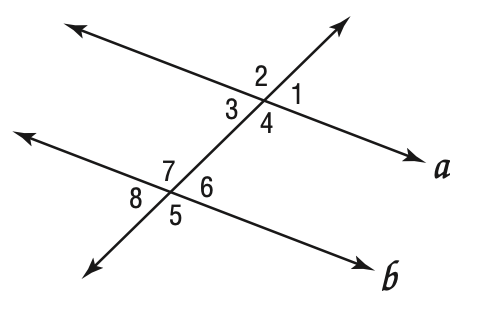Answer the mathemtical geometry problem and directly provide the correct option letter.
Question: If a \parallel b in the diagram below, which of the following may not be true?
Choices: A: \angle 1 \cong \angle 3 B: \angle 2 \cong \angle 5 C: \angle 4 \cong \angle 7 D: \angle 8 \cong \angle 2 D 